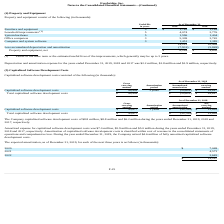According to Everbridge's financial document, What was the company capitalized software development costs during the years ended December 31, 2019? According to the financial document, $8.8 million. The relevant text states: "Company capitalized software development costs of $8.8 million, $8.8 million and $6.2 million during the years ended December 31, 2019, 2018 and 2017, respectivel Company capitalized software developm..." Also, What was the company capitalized software development costs during the years ended December 31, 2018? According to the financial document, $8.8 million. The relevant text states: "Company capitalized software development costs of $8.8 million, $8.8 million and $6.2 million during the years ended December 31, 2019, 2018 and 2017, respectivel Company capitalized software developm..." Also, What was the company capitalized software development costs during the years ended December 31, 2017? According to the financial document, $6.2 million. The relevant text states: "evelopment costs of $8.8 million, $8.8 million and $6.2 million during the years ended December 31, 2019, 2018 and 2017, respectively...." Also, can you calculate: What is the increase/ (decrease) in Gross carrying amount: Capitalized software development costs from December 31, 2019 to December 31, 2018? Based on the calculation: 49,909-45,677, the result is 4232 (in thousands). This is based on the information: "Capitalized software development costs $ 49,909 3 years $ (35,622) $ 14,287 Capitalized software development costs $ 45,677 3 years $ (32,784) $ 12,893..." The key data points involved are: 45,677, 49,909. Also, can you calculate: What is the increase/ (decrease) in Accumulated amortization: Capitalized software development costs from December 31, 2019 to December 31, 2018? Based on the calculation: 35,622-32,784, the result is 2838 (in thousands). This is based on the information: "ed software development costs $ 49,909 3 years $ (35,622) $ 14,287 ed software development costs $ 45,677 3 years $ (32,784) $ 12,893..." The key data points involved are: 32,784, 35,622. Also, can you calculate: What is the increase/ (decrease) in Net carrying amount: Capitalized software development costs from December 31, 2019 to December 31, 2018? Based on the calculation: 14,287-12,893, the result is 1394 (in thousands). This is based on the information: "e development costs $ 45,677 3 years $ (32,784) $ 12,893 e development costs $ 49,909 3 years $ (35,622) $ 14,287..." The key data points involved are: 12,893, 14,287. 